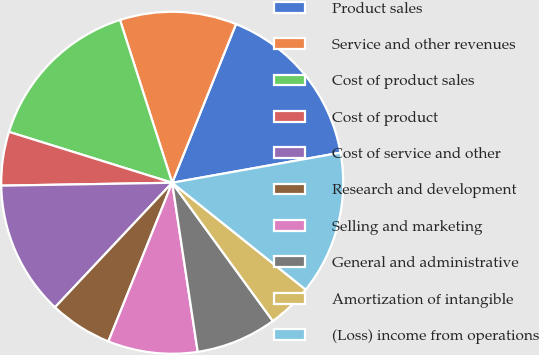Convert chart to OTSL. <chart><loc_0><loc_0><loc_500><loc_500><pie_chart><fcel>Product sales<fcel>Service and other revenues<fcel>Cost of product sales<fcel>Cost of product<fcel>Cost of service and other<fcel>Research and development<fcel>Selling and marketing<fcel>General and administrative<fcel>Amortization of intangible<fcel>(Loss) income from operations<nl><fcel>16.1%<fcel>11.02%<fcel>15.25%<fcel>5.08%<fcel>12.71%<fcel>5.93%<fcel>8.47%<fcel>7.63%<fcel>4.24%<fcel>13.56%<nl></chart> 